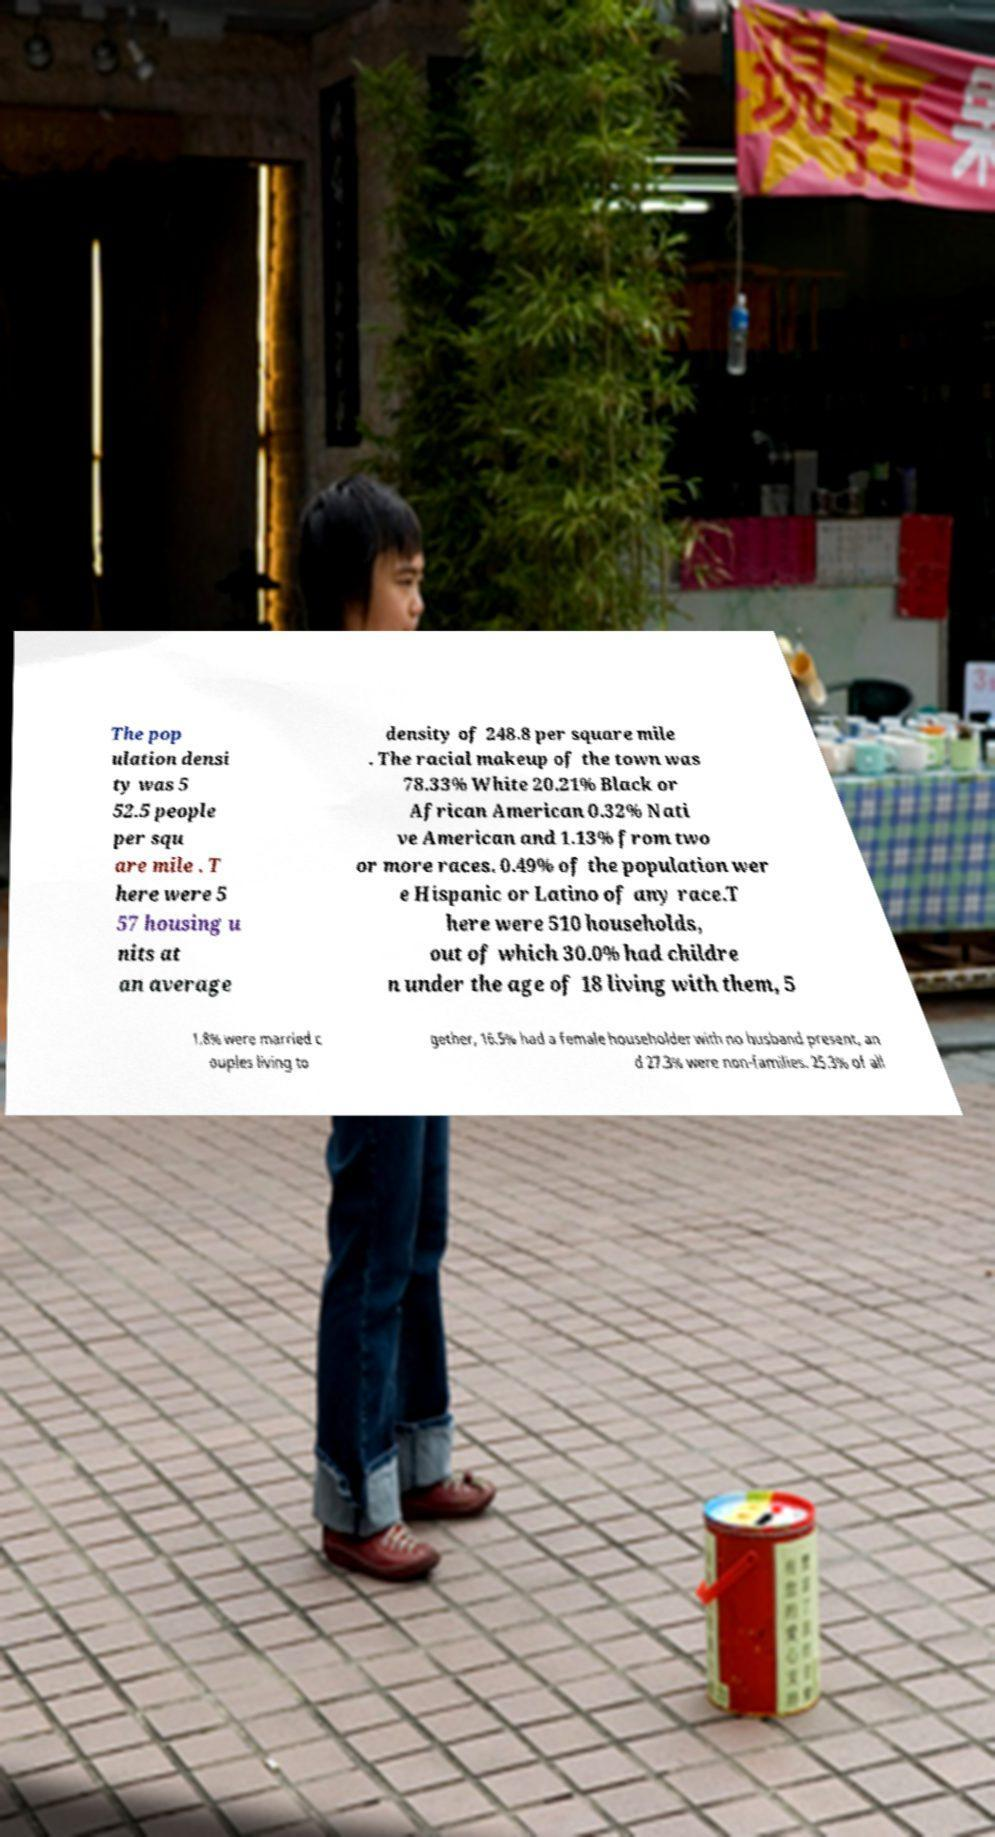Can you read and provide the text displayed in the image?This photo seems to have some interesting text. Can you extract and type it out for me? The pop ulation densi ty was 5 52.5 people per squ are mile . T here were 5 57 housing u nits at an average density of 248.8 per square mile . The racial makeup of the town was 78.33% White 20.21% Black or African American 0.32% Nati ve American and 1.13% from two or more races. 0.49% of the population wer e Hispanic or Latino of any race.T here were 510 households, out of which 30.0% had childre n under the age of 18 living with them, 5 1.8% were married c ouples living to gether, 16.5% had a female householder with no husband present, an d 27.3% were non-families. 25.3% of all 